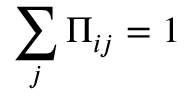Convert formula to latex. <formula><loc_0><loc_0><loc_500><loc_500>\sum _ { j } \Pi _ { i j } = 1</formula> 